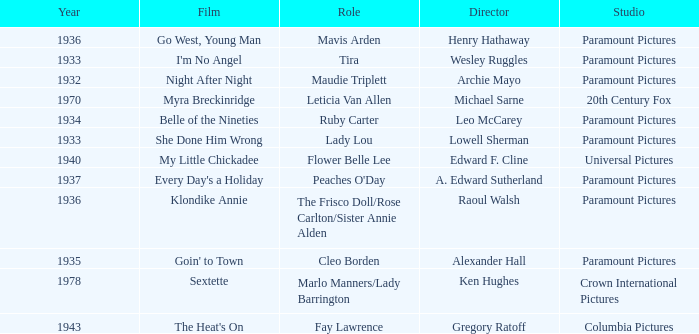What is the Year of the Film Belle of the Nineties? 1934.0. 